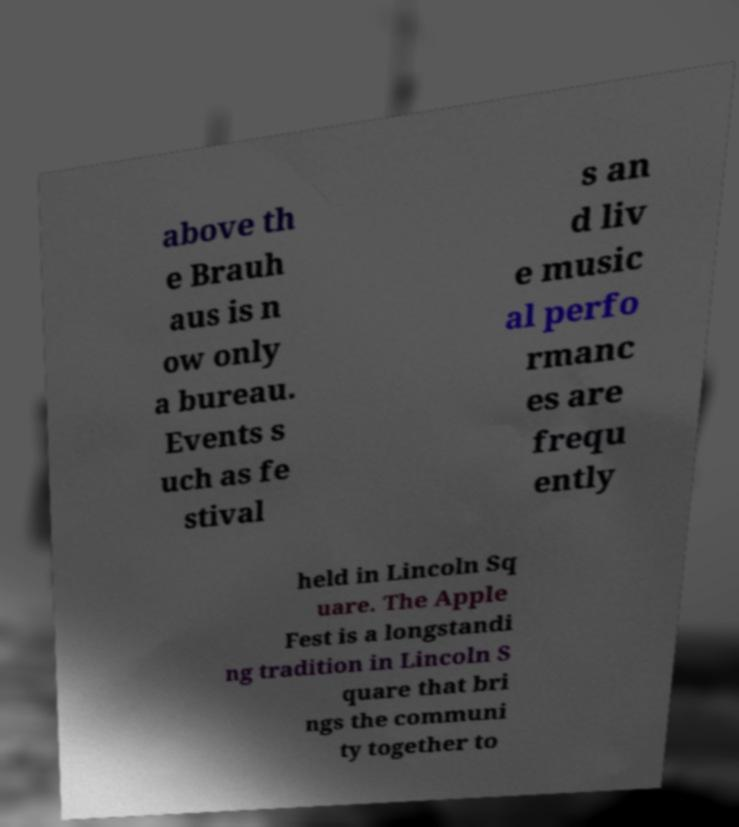Please identify and transcribe the text found in this image. above th e Brauh aus is n ow only a bureau. Events s uch as fe stival s an d liv e music al perfo rmanc es are frequ ently held in Lincoln Sq uare. The Apple Fest is a longstandi ng tradition in Lincoln S quare that bri ngs the communi ty together to 